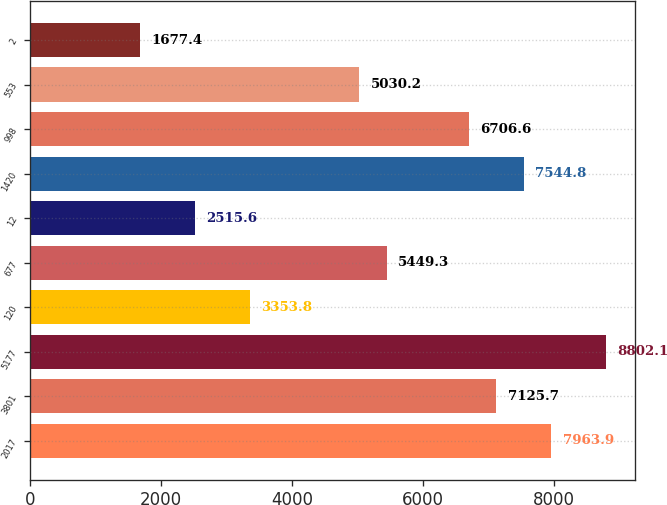<chart> <loc_0><loc_0><loc_500><loc_500><bar_chart><fcel>2017<fcel>3801<fcel>5177<fcel>120<fcel>677<fcel>12<fcel>1420<fcel>998<fcel>553<fcel>2<nl><fcel>7963.9<fcel>7125.7<fcel>8802.1<fcel>3353.8<fcel>5449.3<fcel>2515.6<fcel>7544.8<fcel>6706.6<fcel>5030.2<fcel>1677.4<nl></chart> 